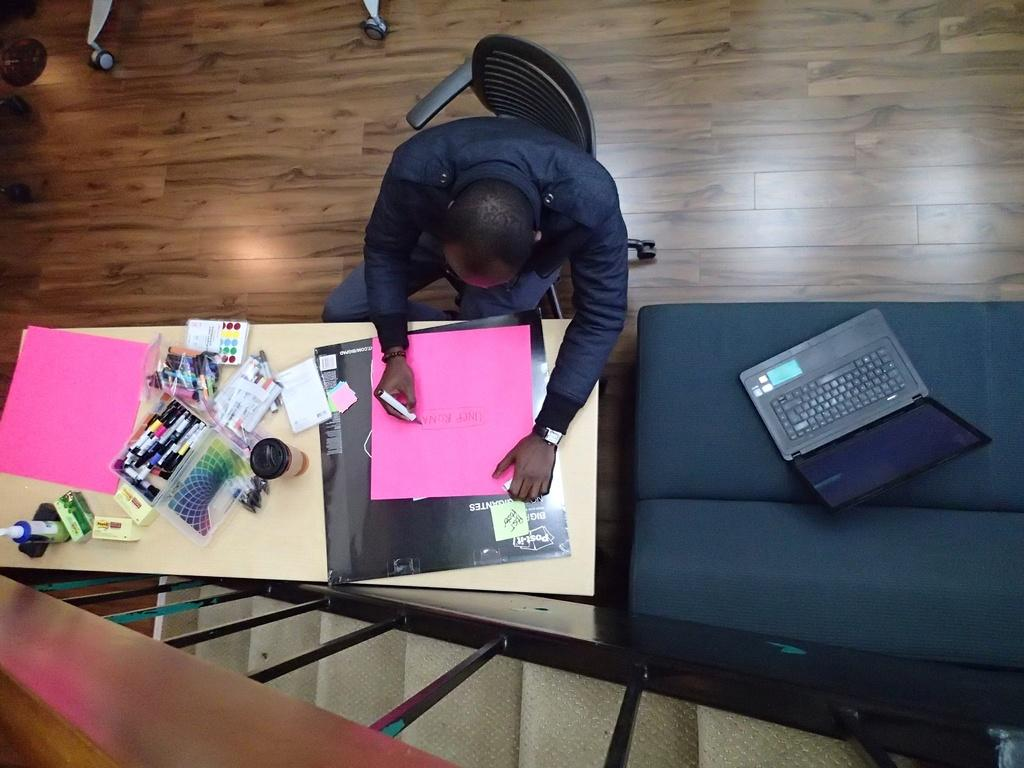What is the person in the image doing? The person is sitting on a chair in the image. What color is the paper visible in the image? The paper is pink in color. What writing instruments can be seen in the image? There are pens in the image. What is on the table in the image? There are objects on a table in the image. Where is the laptop located in the image? The laptop is on a couch in the image. What architectural feature is visible in the image? There are stairs visible in the image. What type of pest can be seen crawling on the pink paper in the image? There are no pests visible in the image, and the pink paper is not mentioned to have any pests on it. How many clovers are present on the table in the image? There is no mention of clovers in the image; the table has objects on it, but not clovers. 